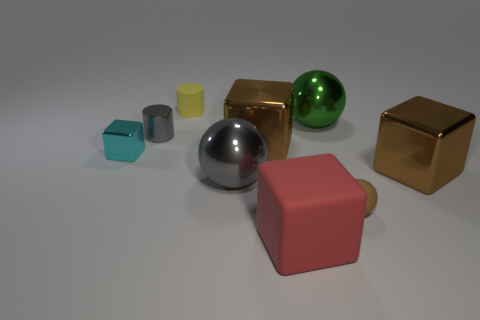Subtract all red cubes. How many cubes are left? 3 Subtract all red rubber blocks. How many blocks are left? 3 Subtract all yellow blocks. Subtract all gray cylinders. How many blocks are left? 4 Subtract all cubes. How many objects are left? 5 Add 3 small cyan matte blocks. How many small cyan matte blocks exist? 3 Subtract 0 purple cylinders. How many objects are left? 9 Subtract all green shiny cylinders. Subtract all brown shiny cubes. How many objects are left? 7 Add 5 large red blocks. How many large red blocks are left? 6 